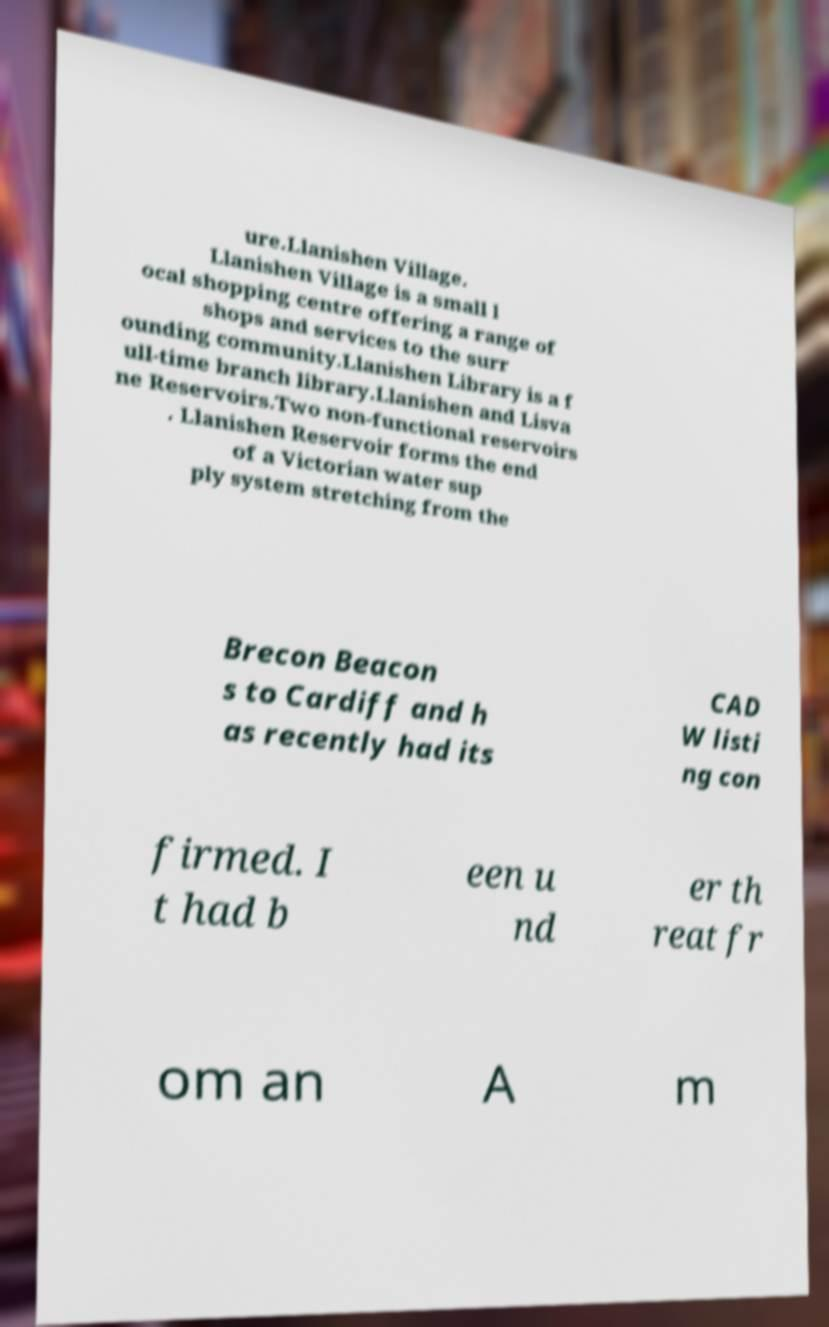Can you accurately transcribe the text from the provided image for me? ure.Llanishen Village. Llanishen Village is a small l ocal shopping centre offering a range of shops and services to the surr ounding community.Llanishen Library is a f ull-time branch library.Llanishen and Lisva ne Reservoirs.Two non-functional reservoirs . Llanishen Reservoir forms the end of a Victorian water sup ply system stretching from the Brecon Beacon s to Cardiff and h as recently had its CAD W listi ng con firmed. I t had b een u nd er th reat fr om an A m 